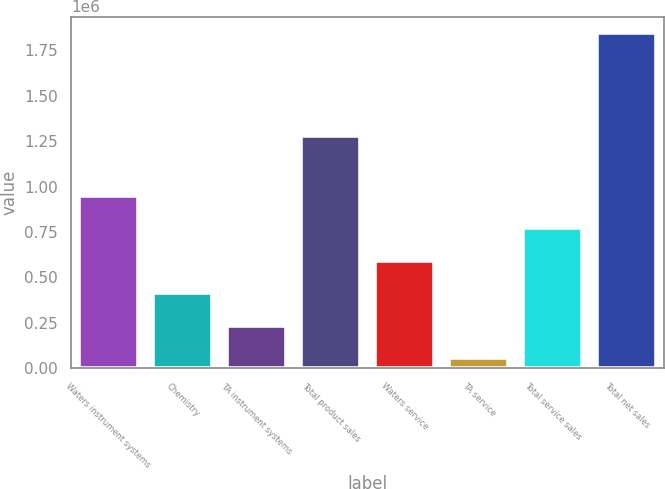Convert chart to OTSL. <chart><loc_0><loc_0><loc_500><loc_500><bar_chart><fcel>Waters instrument systems<fcel>Chemistry<fcel>TA instrument systems<fcel>Total product sales<fcel>Waters service<fcel>TA service<fcel>Total service sales<fcel>Total net sales<nl><fcel>948682<fcel>411706<fcel>232714<fcel>1.28051e+06<fcel>590698<fcel>53722<fcel>769690<fcel>1.84364e+06<nl></chart> 